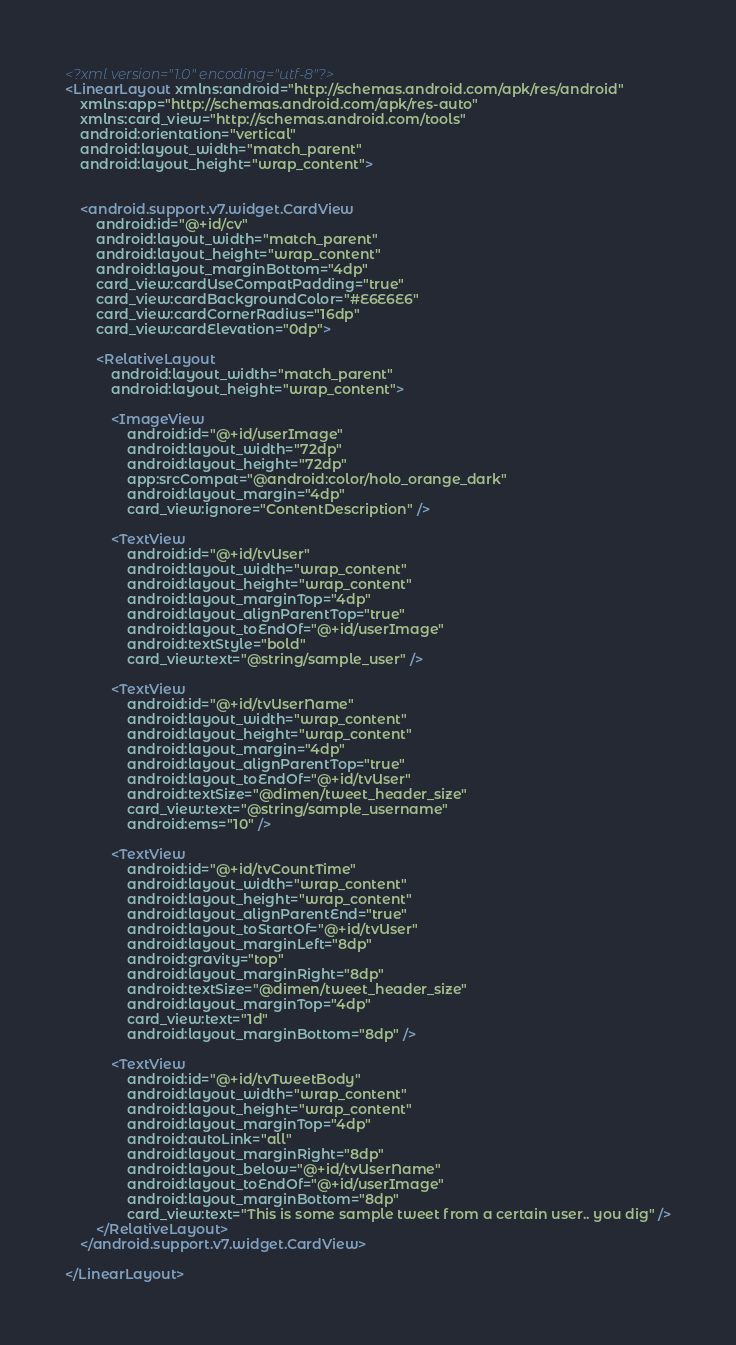<code> <loc_0><loc_0><loc_500><loc_500><_XML_><?xml version="1.0" encoding="utf-8"?>
<LinearLayout xmlns:android="http://schemas.android.com/apk/res/android"
    xmlns:app="http://schemas.android.com/apk/res-auto"
    xmlns:card_view="http://schemas.android.com/tools"
    android:orientation="vertical"
    android:layout_width="match_parent"
    android:layout_height="wrap_content">


    <android.support.v7.widget.CardView
        android:id="@+id/cv"
        android:layout_width="match_parent"
        android:layout_height="wrap_content"
        android:layout_marginBottom="4dp"
        card_view:cardUseCompatPadding="true"
        card_view:cardBackgroundColor="#E6E6E6"
        card_view:cardCornerRadius="16dp"
        card_view:cardElevation="0dp">

        <RelativeLayout
            android:layout_width="match_parent"
            android:layout_height="wrap_content">

            <ImageView
                android:id="@+id/userImage"
                android:layout_width="72dp"
                android:layout_height="72dp"
                app:srcCompat="@android:color/holo_orange_dark"
                android:layout_margin="4dp"
                card_view:ignore="ContentDescription" />

            <TextView
                android:id="@+id/tvUser"
                android:layout_width="wrap_content"
                android:layout_height="wrap_content"
                android:layout_marginTop="4dp"
                android:layout_alignParentTop="true"
                android:layout_toEndOf="@+id/userImage"
                android:textStyle="bold"
                card_view:text="@string/sample_user" />

            <TextView
                android:id="@+id/tvUserName"
                android:layout_width="wrap_content"
                android:layout_height="wrap_content"
                android:layout_margin="4dp"
                android:layout_alignParentTop="true"
                android:layout_toEndOf="@+id/tvUser"
                android:textSize="@dimen/tweet_header_size"
                card_view:text="@string/sample_username"
                android:ems="10" />

            <TextView
                android:id="@+id/tvCountTime"
                android:layout_width="wrap_content"
                android:layout_height="wrap_content"
                android:layout_alignParentEnd="true"
                android:layout_toStartOf="@+id/tvUser"
                android:layout_marginLeft="8dp"
                android:gravity="top"
                android:layout_marginRight="8dp"
                android:textSize="@dimen/tweet_header_size"
                android:layout_marginTop="4dp"
                card_view:text="1d"
                android:layout_marginBottom="8dp" />

            <TextView
                android:id="@+id/tvTweetBody"
                android:layout_width="wrap_content"
                android:layout_height="wrap_content"
                android:layout_marginTop="4dp"
                android:autoLink="all"
                android:layout_marginRight="8dp"
                android:layout_below="@+id/tvUserName"
                android:layout_toEndOf="@+id/userImage"
                android:layout_marginBottom="8dp"
                card_view:text="This is some sample tweet from a certain user.. you dig" />
        </RelativeLayout>
    </android.support.v7.widget.CardView>

</LinearLayout></code> 